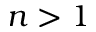<formula> <loc_0><loc_0><loc_500><loc_500>n > 1</formula> 